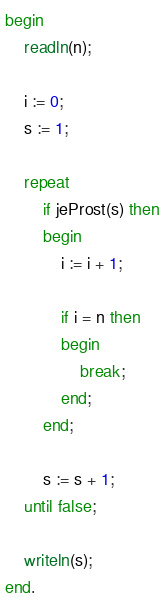<code> <loc_0><loc_0><loc_500><loc_500><_Pascal_>begin
	readln(n);

	i := 0;
	s := 1;

	repeat
		if jeProst(s) then
		begin
			i := i + 1;
			
			if i = n then
			begin
				break;
			end;
		end;
		
		s := s + 1;
	until false;

	writeln(s);
end.
</code> 